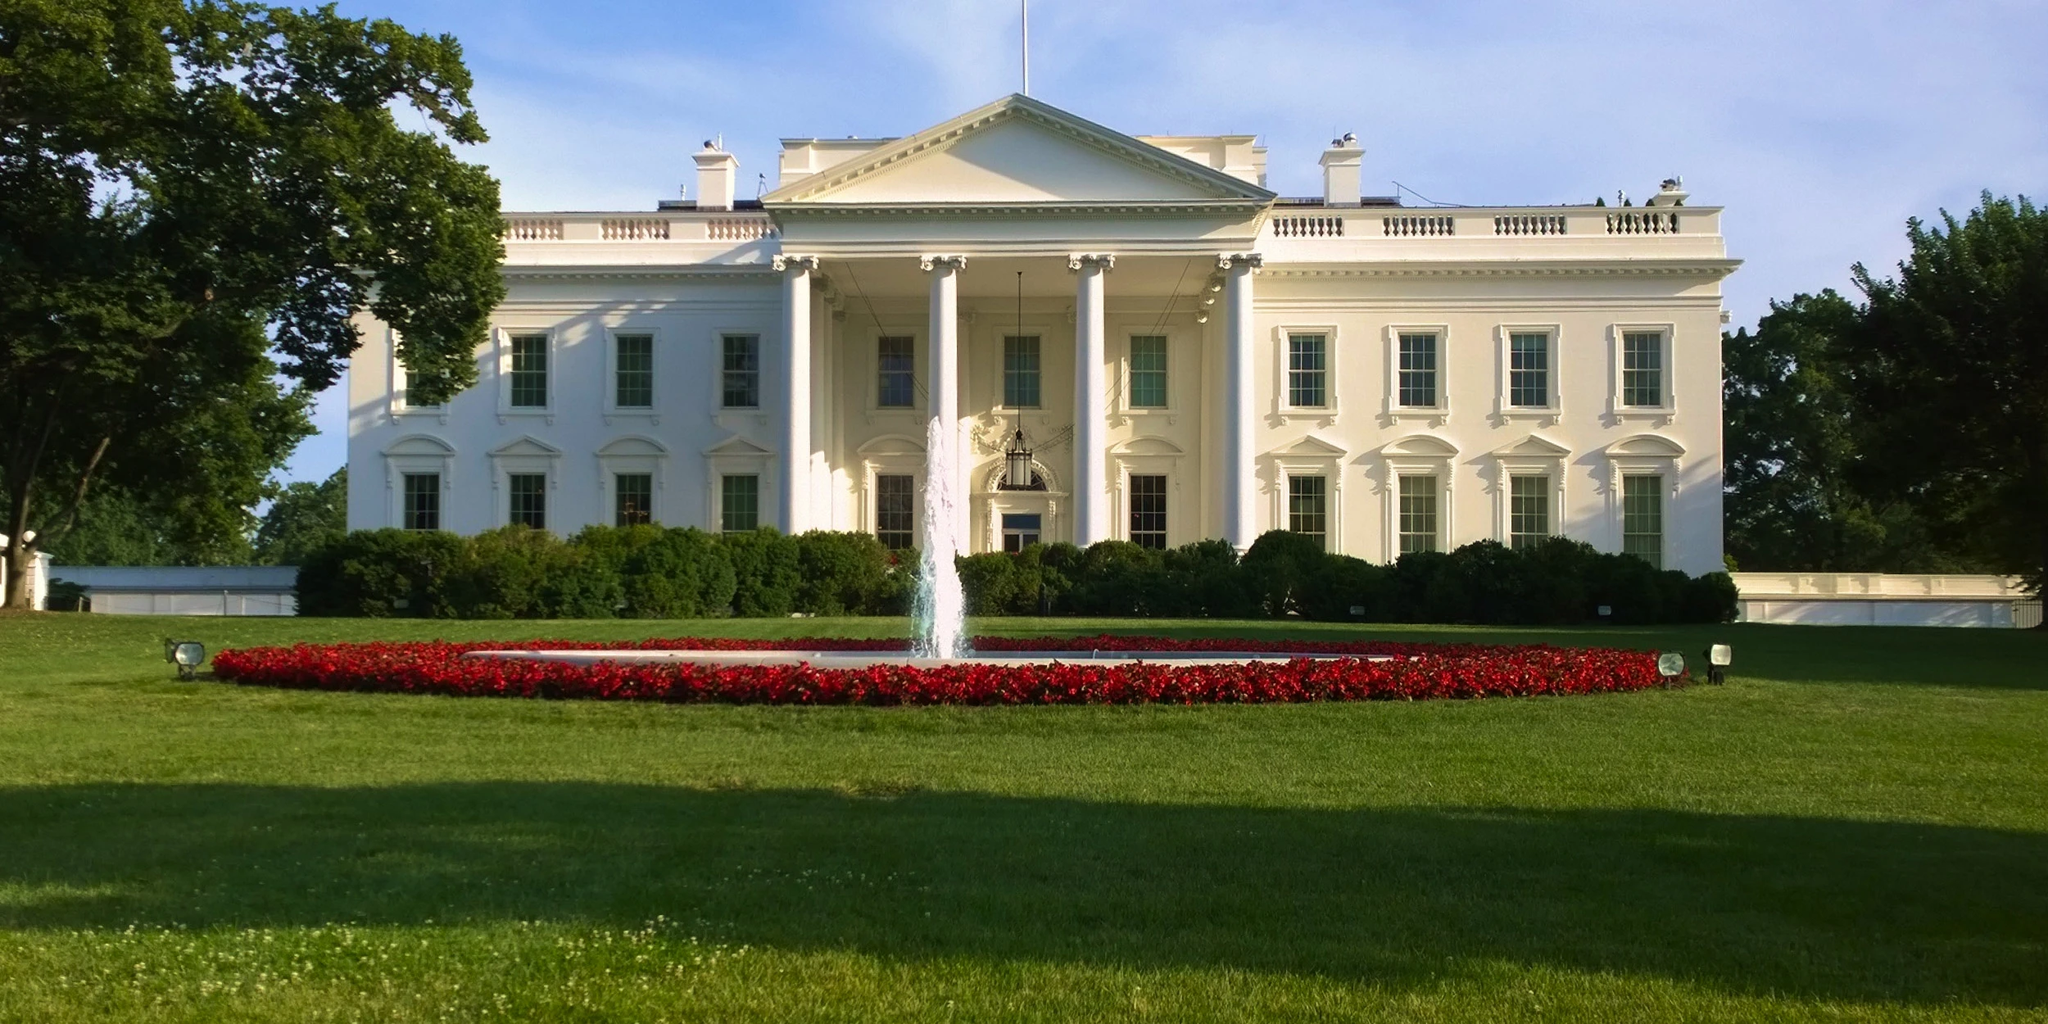Can you explain the significance of the fountain in front of the White House? Certainly! The fountain located on the North Lawn of the White House serves not only as an aesthetic feature but also symbolizes tranquility and order. It's a visual focal point that complements the neoclassical style of the building and has been part of the landscape since the early 20th century, offering a serene ambiance to this historically charged locale. 